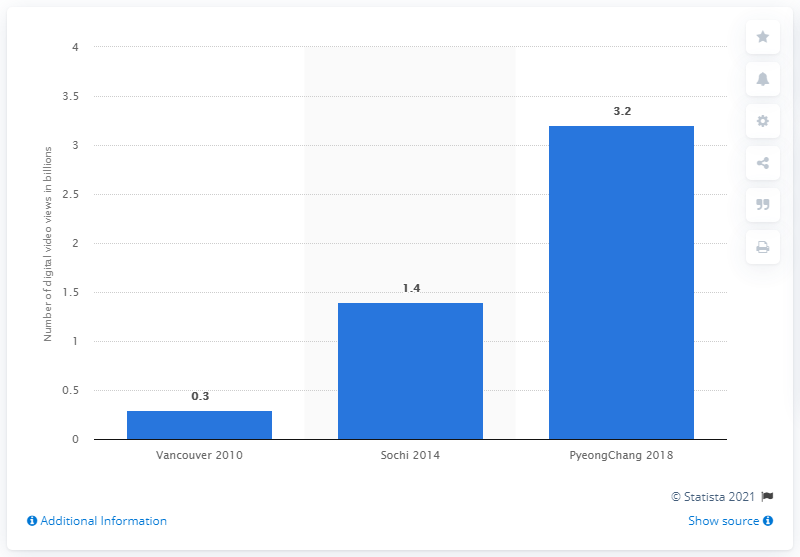Indicate a few pertinent items in this graphic. There were approximately 3.2 billion digital video views at the 2018 PyeongChang Winter Olympics. 